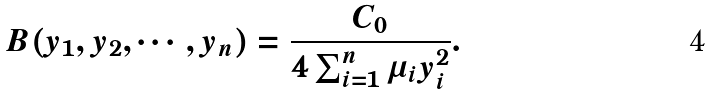<formula> <loc_0><loc_0><loc_500><loc_500>B ( y _ { 1 } , y _ { 2 } , \cdots , y _ { n } ) = \frac { C _ { 0 } } { 4 \sum _ { i = 1 } ^ { n } \mu _ { i } y _ { i } ^ { 2 } } .</formula> 